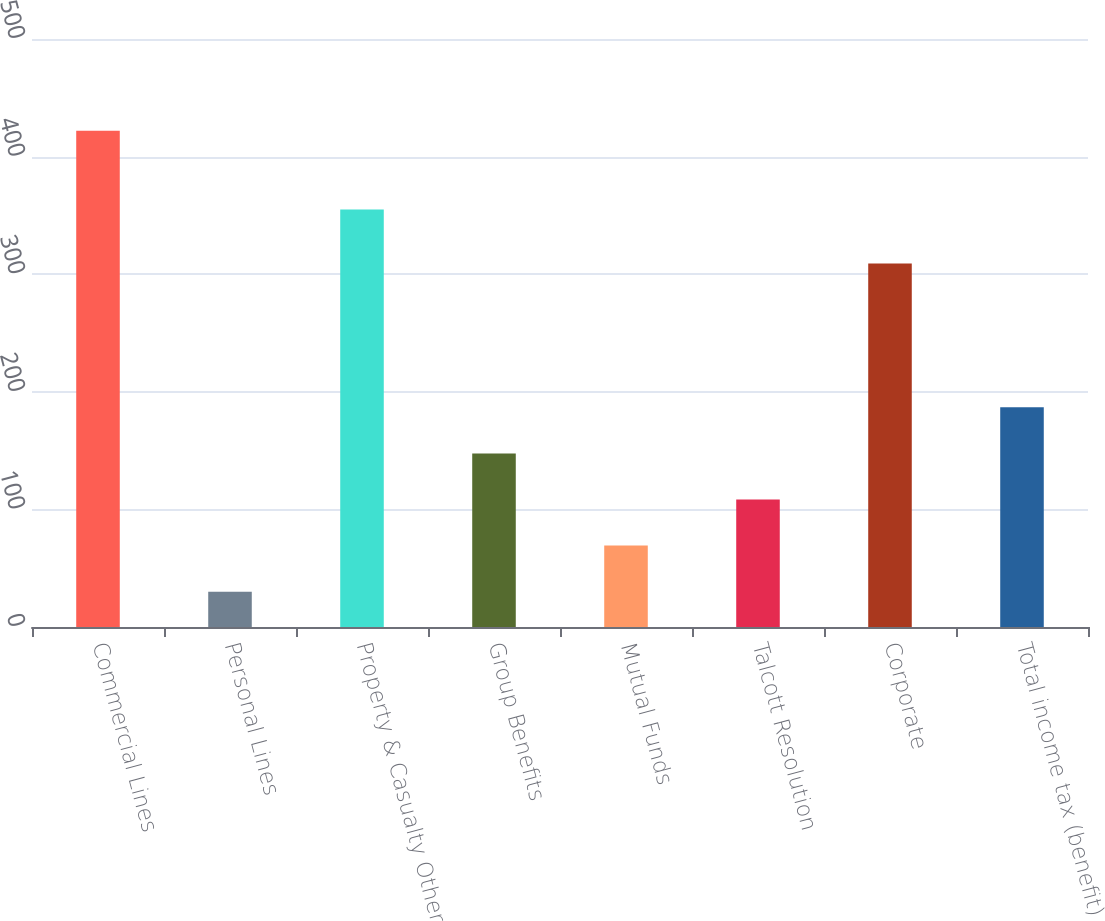Convert chart. <chart><loc_0><loc_0><loc_500><loc_500><bar_chart><fcel>Commercial Lines<fcel>Personal Lines<fcel>Property & Casualty Other<fcel>Group Benefits<fcel>Mutual Funds<fcel>Talcott Resolution<fcel>Corporate<fcel>Total income tax (benefit)<nl><fcel>422<fcel>30<fcel>355<fcel>147.6<fcel>69.2<fcel>108.4<fcel>309<fcel>186.8<nl></chart> 